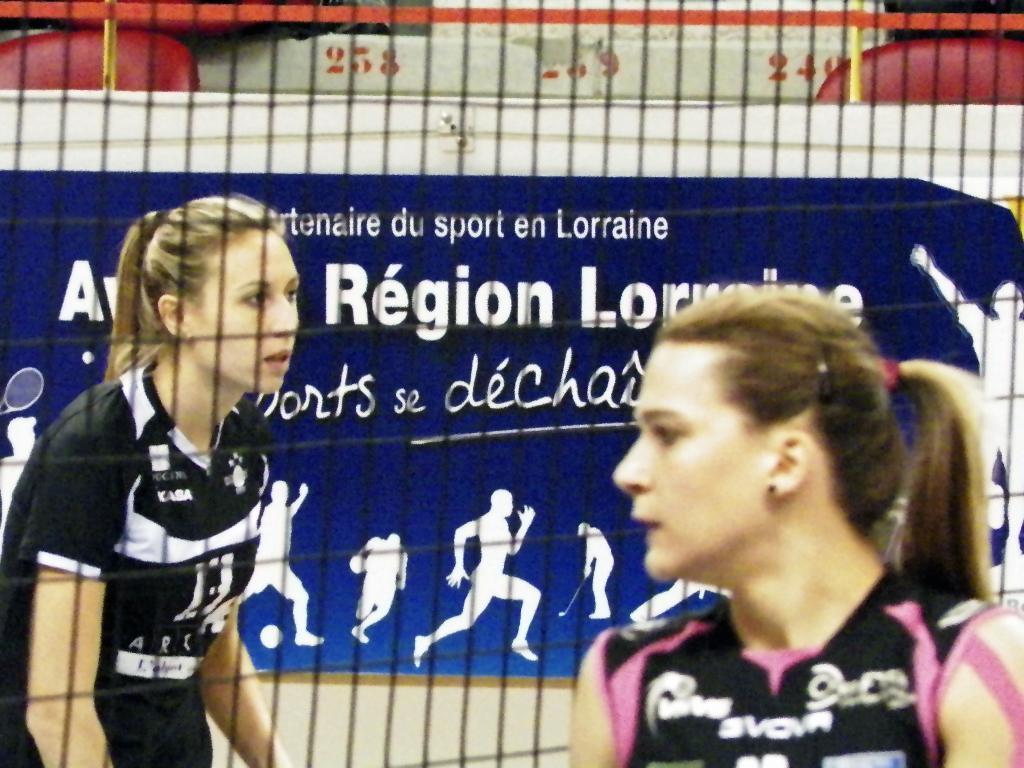Could you give a brief overview of what you see in this image? In this picture there is a woman with black and pink t-shirt and there is a woman with black and white t-shirt behind the fence and there is a board and there is text and there are pictures of group of people on the board and there are chairs. 